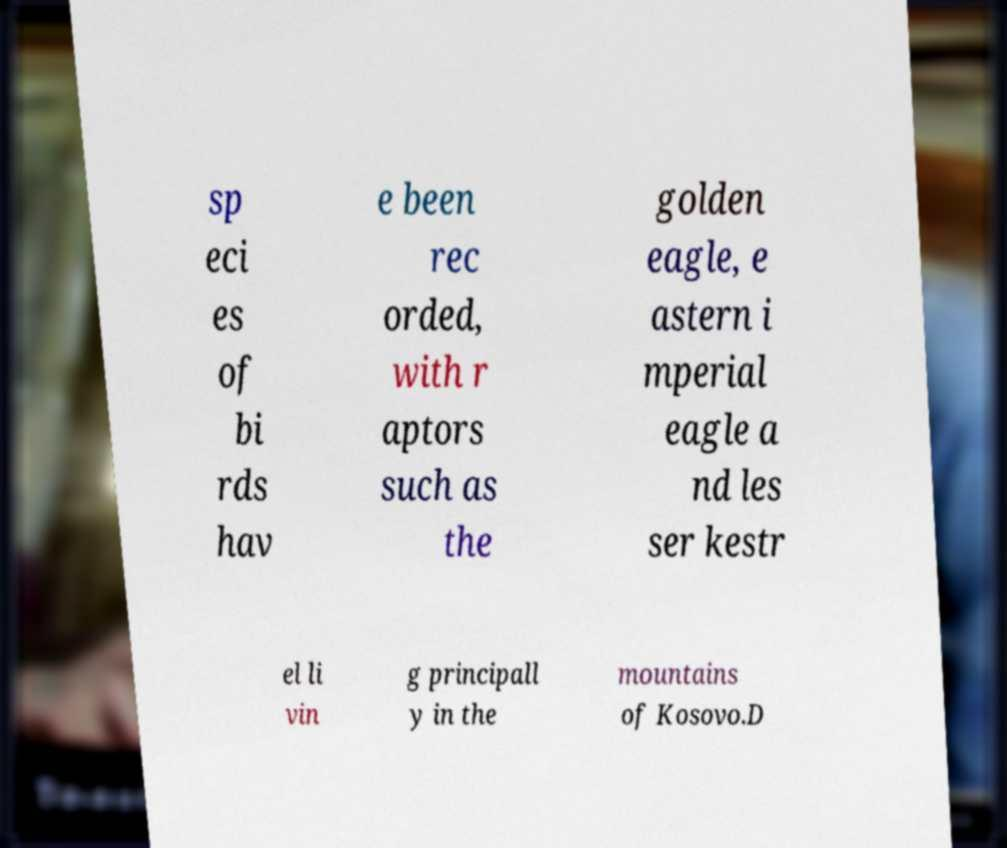There's text embedded in this image that I need extracted. Can you transcribe it verbatim? sp eci es of bi rds hav e been rec orded, with r aptors such as the golden eagle, e astern i mperial eagle a nd les ser kestr el li vin g principall y in the mountains of Kosovo.D 